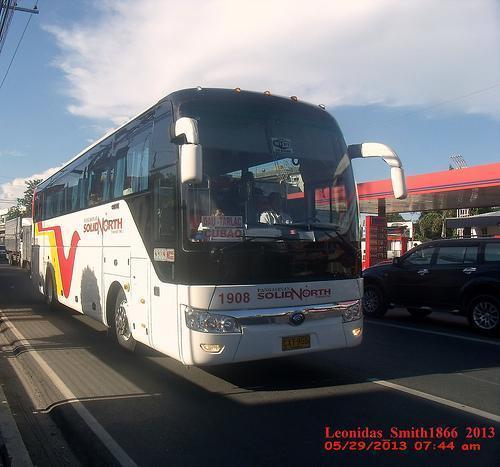How many busses?
Give a very brief answer. 1. 